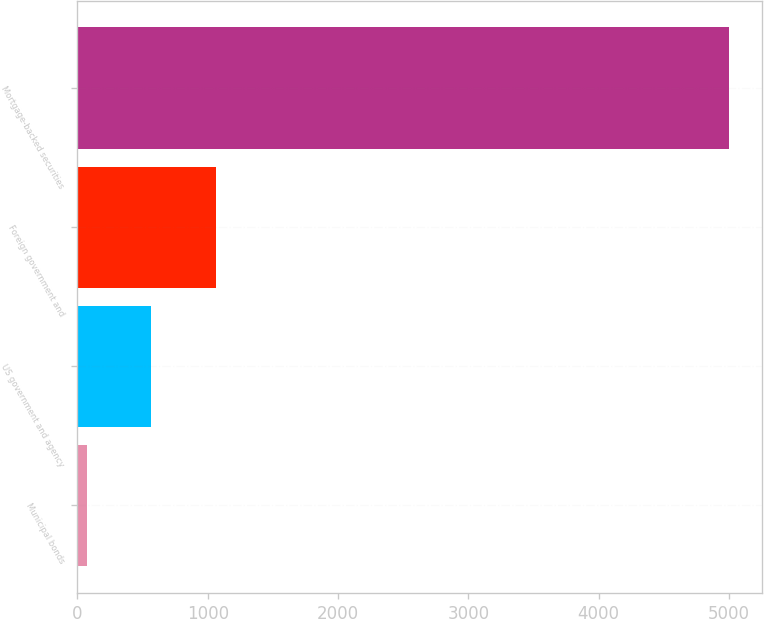<chart> <loc_0><loc_0><loc_500><loc_500><bar_chart><fcel>Municipal bonds<fcel>US government and agency<fcel>Foreign government and<fcel>Mortgage-backed securities<nl><fcel>74<fcel>567<fcel>1060<fcel>5004<nl></chart> 